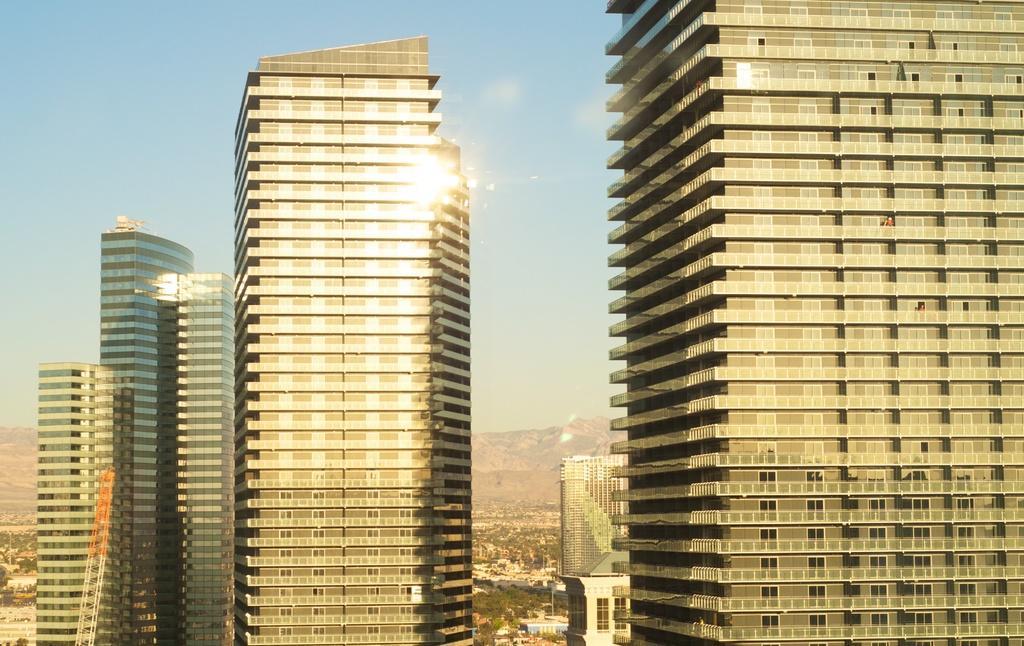Could you give a brief overview of what you see in this image? In the picture we can see tower buildings and behind it, we can see some trees at the bottom of the buildings and we can see some hills and sky. 